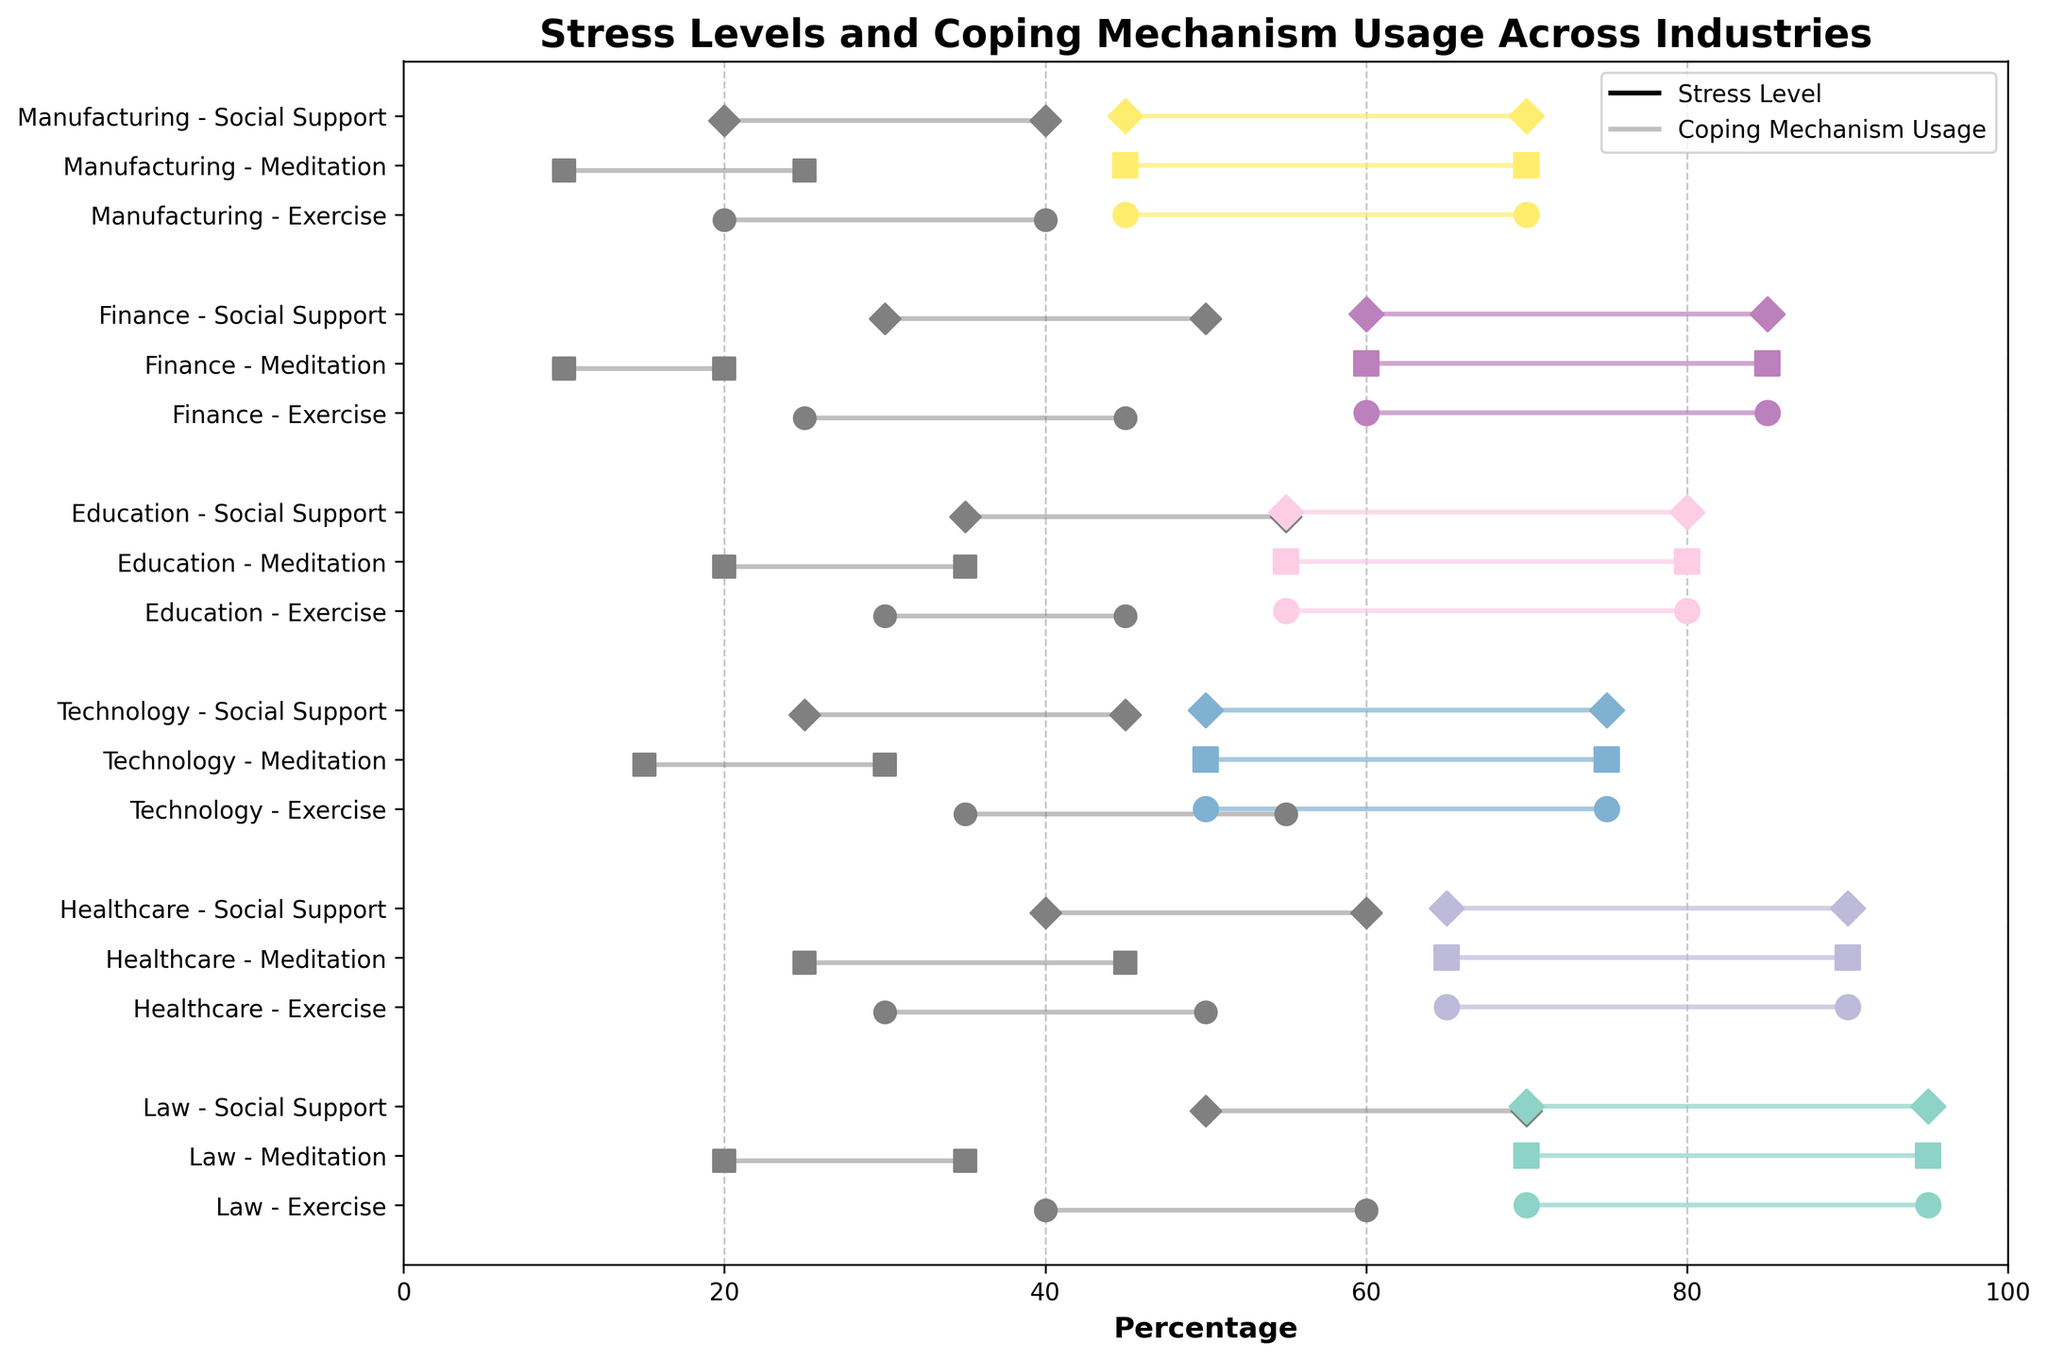What's the title of the graph? The title is located at the top of the chart, displaying the subject of the figure.
Answer: Stress Levels and Coping Mechanism Usage Across Industries Which industry has the highest upper range of stress levels? The upper range of stress levels is represented by the rightmost endpoint of the horizontal lines for each industry. The Law industry has the highest upper stress level at 95%.
Answer: Law Which coping mechanism is the least utilized in the Finance industry? The least utilized coping mechanism can be found by identifying the shortest horizontal gray line within the Finance industry. Meditation in Finance has the lowest range, from 10% to 20%.
Answer: Meditation How does the stress level range for the Healthcare industry compare to the Manufacturing industry? The stress level range for each industry is visible by looking at the endpoints of the colored horizontal lines. Healthcare ranges from 65% to 90%, while Manufacturing ranges from 45% to 70%.
Answer: Healthcare has a higher range compared to Manufacturing Which industry has the most similar stress level range to Technology? Compare the start and endpoints of the stress level bars for each industry to that of Technology, which ranges from 50% to 75%. Education has a similar range of 55% to 80%.
Answer: Education What is the difference between the upper limit of coping mechanism usage for Exercise in Law and Meditation in Technology? Identify the upper limits for each coping mechanism: Exercise in Law is from 40% to 60%, and Meditation in Technology is from 15% to 30%. Subtract 30 from 60.
Answer: 30% In which industry is Social Support utilized the most? Check the longest horizontal gray line for Social Support across all industries. Law has the highest utilization ranging from 50% to 70%.
Answer: Law What is the average lower limit of stress levels across all industries? Add the lower stress levels for each industry and divide by the number of industries: (70+65+50+55+60+45)/6 = 57.5%.
Answer: 57.5% Compare the stress level range of Finance and Education industries. Which one is wider? Calculate the difference between the upper and lower bounds for each industry. Finance ranges from 60% to 85% (25% range), Education from 55% to 80% (25% range). Both have the same range.
Answer: They have the same range Which industry shows the highest usage of Meditation? Look for the longest horizontal gray line of Meditation. Healthcare shows a Meditation range of 25% to 45%, which is the highest among visible industries.
Answer: Healthcare 